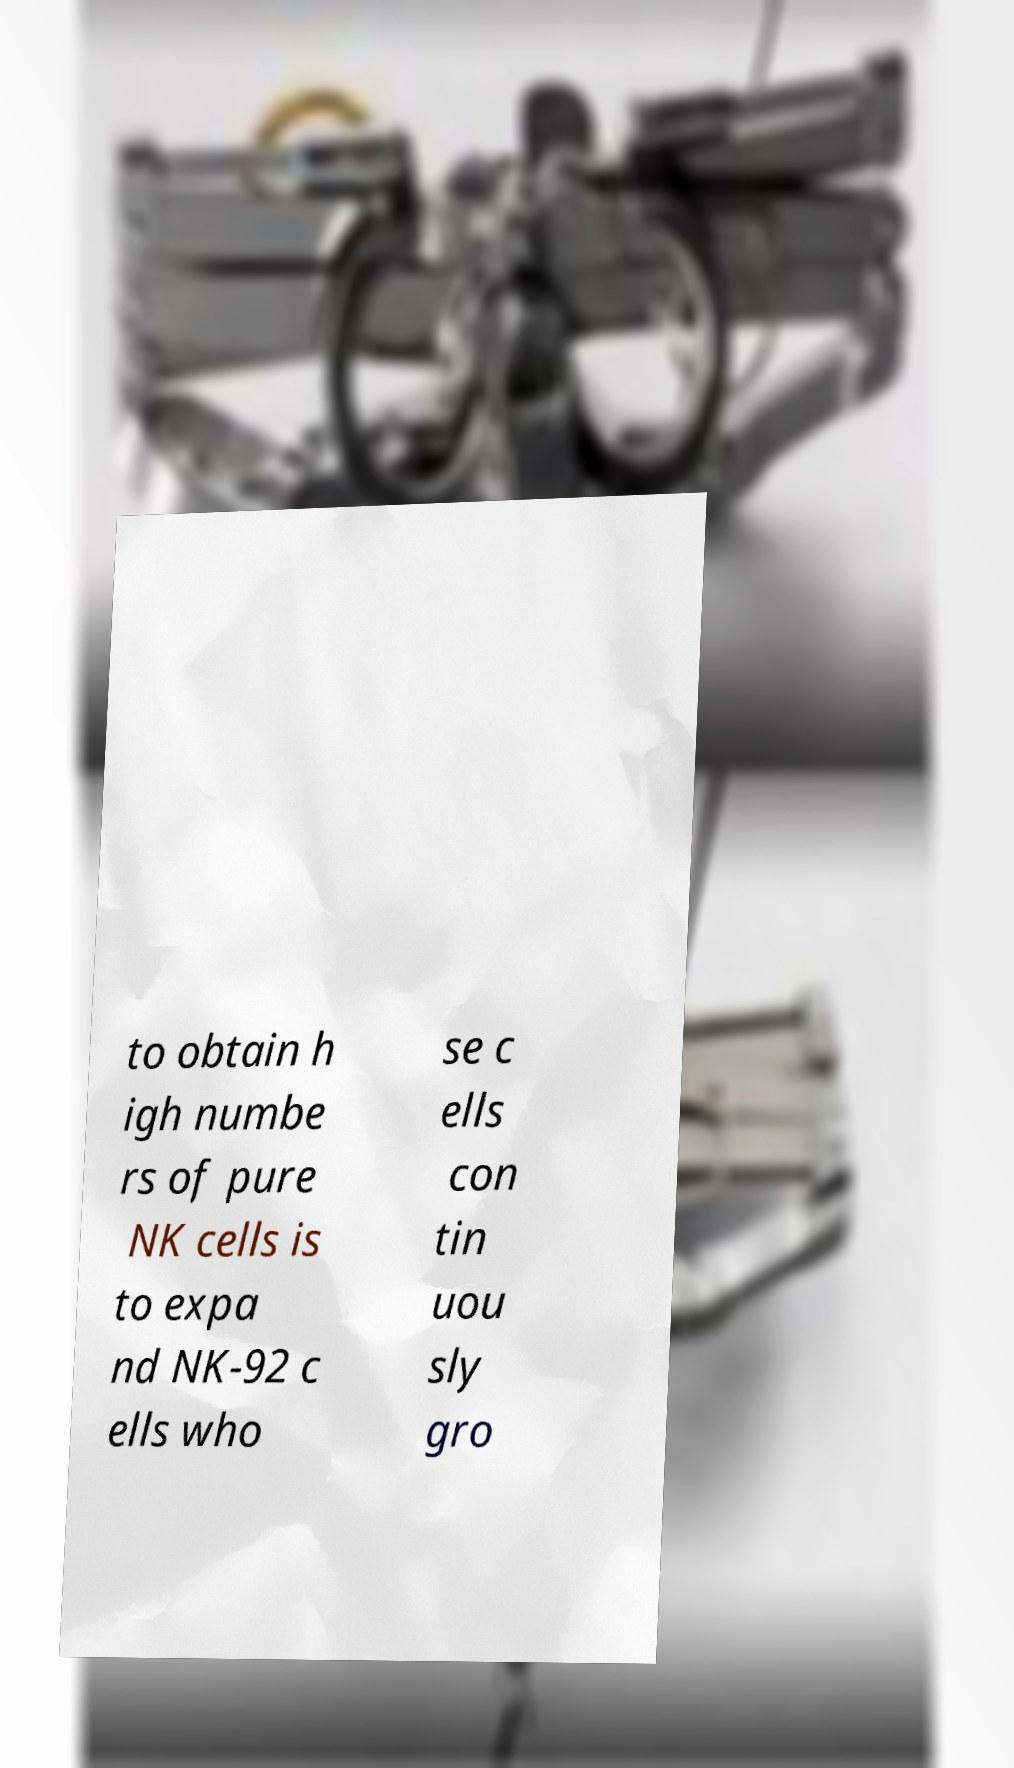Could you assist in decoding the text presented in this image and type it out clearly? to obtain h igh numbe rs of pure NK cells is to expa nd NK-92 c ells who se c ells con tin uou sly gro 